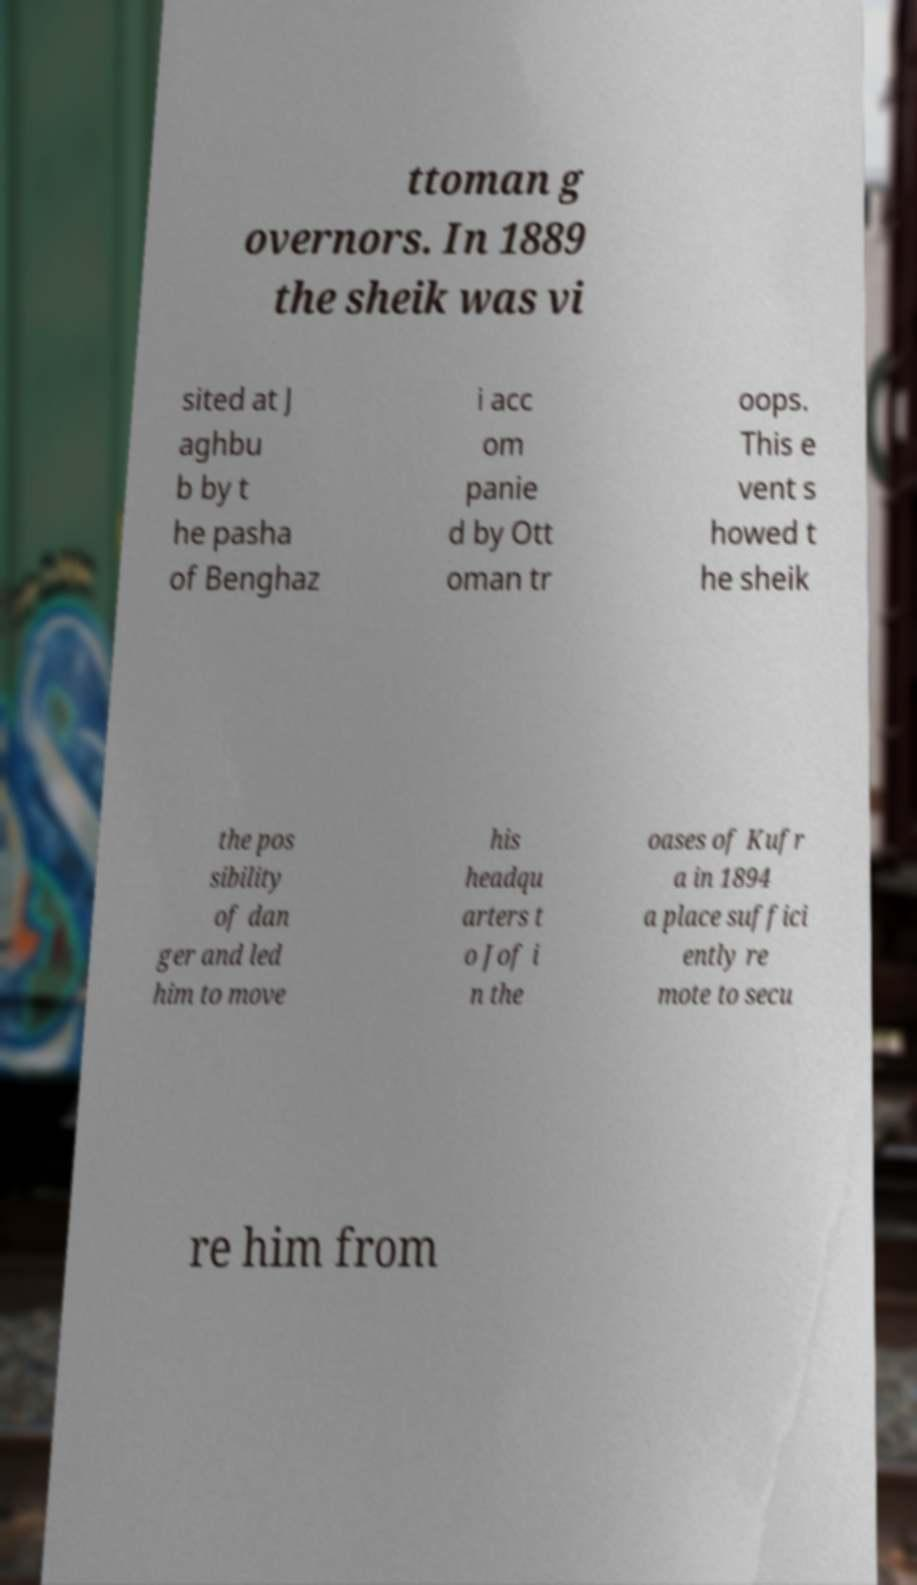Can you accurately transcribe the text from the provided image for me? ttoman g overnors. In 1889 the sheik was vi sited at J aghbu b by t he pasha of Benghaz i acc om panie d by Ott oman tr oops. This e vent s howed t he sheik the pos sibility of dan ger and led him to move his headqu arters t o Jof i n the oases of Kufr a in 1894 a place suffici ently re mote to secu re him from 